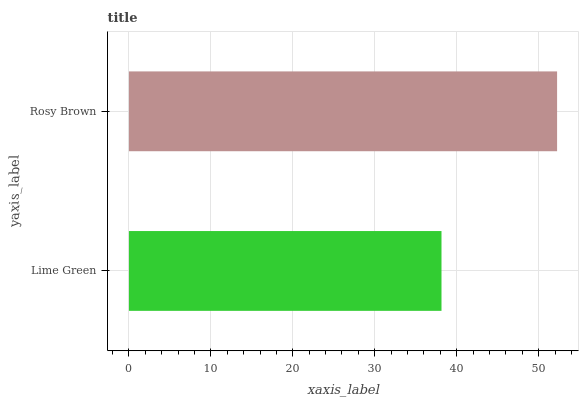Is Lime Green the minimum?
Answer yes or no. Yes. Is Rosy Brown the maximum?
Answer yes or no. Yes. Is Rosy Brown the minimum?
Answer yes or no. No. Is Rosy Brown greater than Lime Green?
Answer yes or no. Yes. Is Lime Green less than Rosy Brown?
Answer yes or no. Yes. Is Lime Green greater than Rosy Brown?
Answer yes or no. No. Is Rosy Brown less than Lime Green?
Answer yes or no. No. Is Rosy Brown the high median?
Answer yes or no. Yes. Is Lime Green the low median?
Answer yes or no. Yes. Is Lime Green the high median?
Answer yes or no. No. Is Rosy Brown the low median?
Answer yes or no. No. 